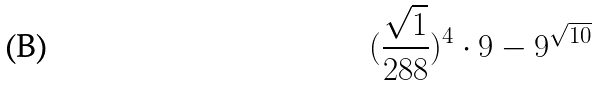Convert formula to latex. <formula><loc_0><loc_0><loc_500><loc_500>( \frac { \sqrt { 1 } } { 2 8 8 } ) ^ { 4 } \cdot 9 - 9 ^ { \sqrt { 1 0 } }</formula> 